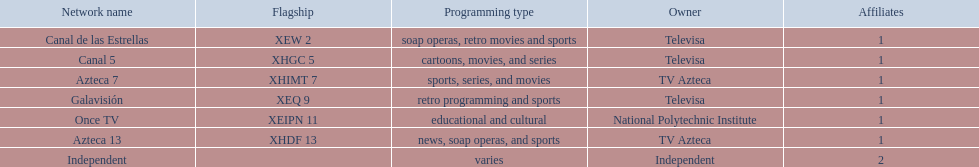What channels broadcast sports? Soap operas, retro movies and sports, retro programming and sports, news, soap operas, and sports. Which of these is not associated with televisa? Azteca 7. 